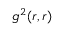<formula> <loc_0><loc_0><loc_500><loc_500>g ^ { 2 } ( r , r )</formula> 